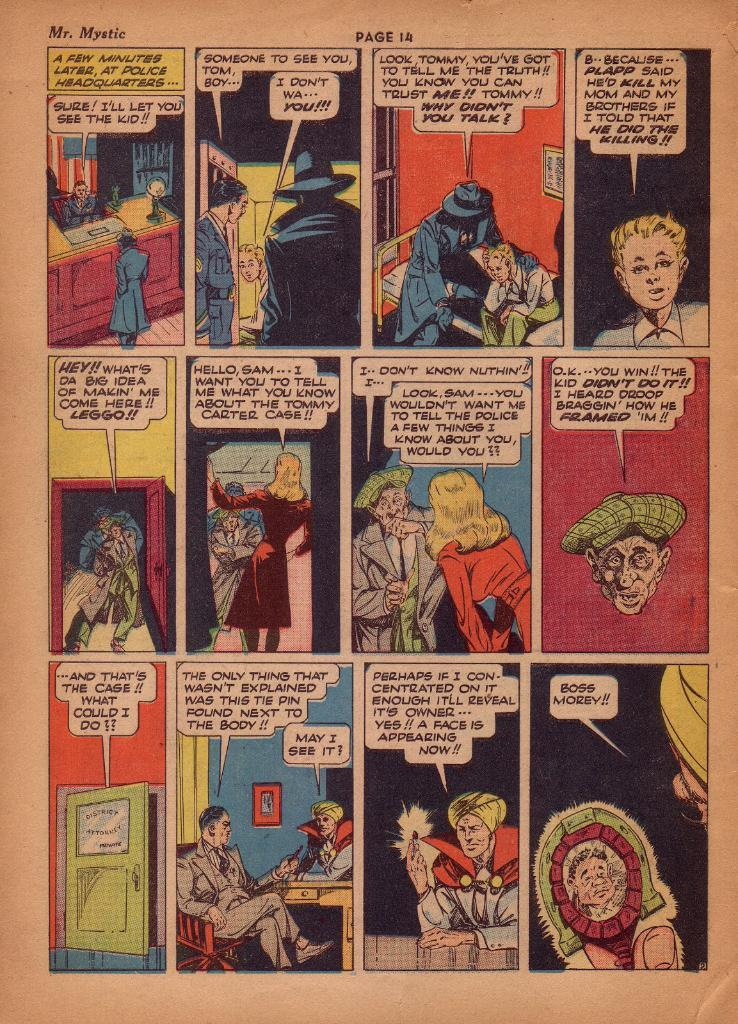<image>
Describe the image concisely. A comic book of Mr. Mystic open to page 14 with various characters 